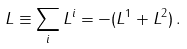<formula> <loc_0><loc_0><loc_500><loc_500>L \equiv \sum _ { i } L ^ { i } = - ( L ^ { 1 } + L ^ { 2 } ) \, .</formula> 